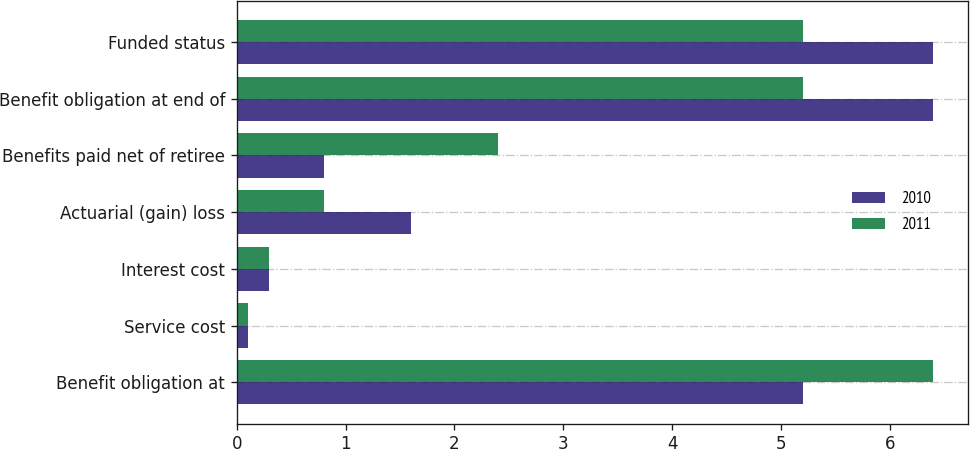<chart> <loc_0><loc_0><loc_500><loc_500><stacked_bar_chart><ecel><fcel>Benefit obligation at<fcel>Service cost<fcel>Interest cost<fcel>Actuarial (gain) loss<fcel>Benefits paid net of retiree<fcel>Benefit obligation at end of<fcel>Funded status<nl><fcel>2010<fcel>5.2<fcel>0.1<fcel>0.3<fcel>1.6<fcel>0.8<fcel>6.4<fcel>6.4<nl><fcel>2011<fcel>6.4<fcel>0.1<fcel>0.3<fcel>0.8<fcel>2.4<fcel>5.2<fcel>5.2<nl></chart> 